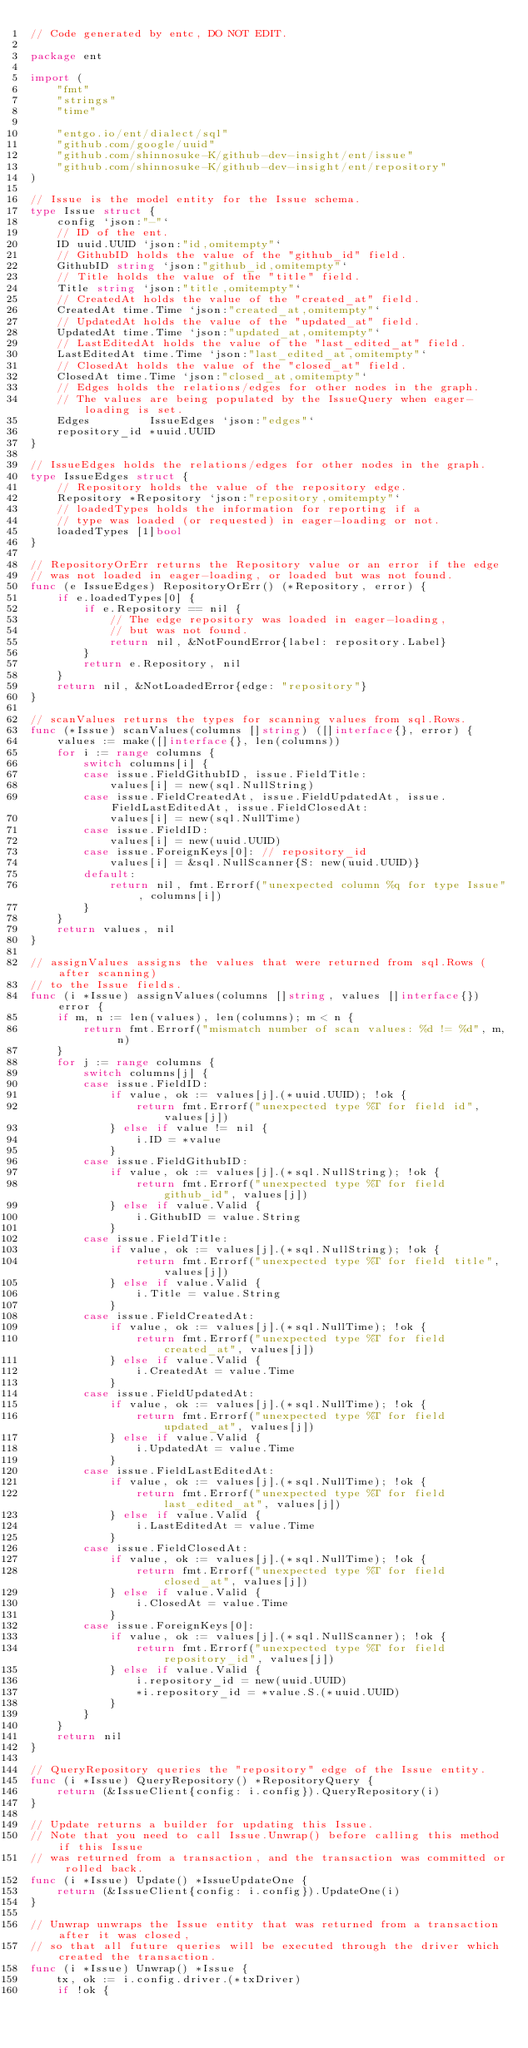<code> <loc_0><loc_0><loc_500><loc_500><_Go_>// Code generated by entc, DO NOT EDIT.

package ent

import (
	"fmt"
	"strings"
	"time"

	"entgo.io/ent/dialect/sql"
	"github.com/google/uuid"
	"github.com/shinnosuke-K/github-dev-insight/ent/issue"
	"github.com/shinnosuke-K/github-dev-insight/ent/repository"
)

// Issue is the model entity for the Issue schema.
type Issue struct {
	config `json:"-"`
	// ID of the ent.
	ID uuid.UUID `json:"id,omitempty"`
	// GithubID holds the value of the "github_id" field.
	GithubID string `json:"github_id,omitempty"`
	// Title holds the value of the "title" field.
	Title string `json:"title,omitempty"`
	// CreatedAt holds the value of the "created_at" field.
	CreatedAt time.Time `json:"created_at,omitempty"`
	// UpdatedAt holds the value of the "updated_at" field.
	UpdatedAt time.Time `json:"updated_at,omitempty"`
	// LastEditedAt holds the value of the "last_edited_at" field.
	LastEditedAt time.Time `json:"last_edited_at,omitempty"`
	// ClosedAt holds the value of the "closed_at" field.
	ClosedAt time.Time `json:"closed_at,omitempty"`
	// Edges holds the relations/edges for other nodes in the graph.
	// The values are being populated by the IssueQuery when eager-loading is set.
	Edges         IssueEdges `json:"edges"`
	repository_id *uuid.UUID
}

// IssueEdges holds the relations/edges for other nodes in the graph.
type IssueEdges struct {
	// Repository holds the value of the repository edge.
	Repository *Repository `json:"repository,omitempty"`
	// loadedTypes holds the information for reporting if a
	// type was loaded (or requested) in eager-loading or not.
	loadedTypes [1]bool
}

// RepositoryOrErr returns the Repository value or an error if the edge
// was not loaded in eager-loading, or loaded but was not found.
func (e IssueEdges) RepositoryOrErr() (*Repository, error) {
	if e.loadedTypes[0] {
		if e.Repository == nil {
			// The edge repository was loaded in eager-loading,
			// but was not found.
			return nil, &NotFoundError{label: repository.Label}
		}
		return e.Repository, nil
	}
	return nil, &NotLoadedError{edge: "repository"}
}

// scanValues returns the types for scanning values from sql.Rows.
func (*Issue) scanValues(columns []string) ([]interface{}, error) {
	values := make([]interface{}, len(columns))
	for i := range columns {
		switch columns[i] {
		case issue.FieldGithubID, issue.FieldTitle:
			values[i] = new(sql.NullString)
		case issue.FieldCreatedAt, issue.FieldUpdatedAt, issue.FieldLastEditedAt, issue.FieldClosedAt:
			values[i] = new(sql.NullTime)
		case issue.FieldID:
			values[i] = new(uuid.UUID)
		case issue.ForeignKeys[0]: // repository_id
			values[i] = &sql.NullScanner{S: new(uuid.UUID)}
		default:
			return nil, fmt.Errorf("unexpected column %q for type Issue", columns[i])
		}
	}
	return values, nil
}

// assignValues assigns the values that were returned from sql.Rows (after scanning)
// to the Issue fields.
func (i *Issue) assignValues(columns []string, values []interface{}) error {
	if m, n := len(values), len(columns); m < n {
		return fmt.Errorf("mismatch number of scan values: %d != %d", m, n)
	}
	for j := range columns {
		switch columns[j] {
		case issue.FieldID:
			if value, ok := values[j].(*uuid.UUID); !ok {
				return fmt.Errorf("unexpected type %T for field id", values[j])
			} else if value != nil {
				i.ID = *value
			}
		case issue.FieldGithubID:
			if value, ok := values[j].(*sql.NullString); !ok {
				return fmt.Errorf("unexpected type %T for field github_id", values[j])
			} else if value.Valid {
				i.GithubID = value.String
			}
		case issue.FieldTitle:
			if value, ok := values[j].(*sql.NullString); !ok {
				return fmt.Errorf("unexpected type %T for field title", values[j])
			} else if value.Valid {
				i.Title = value.String
			}
		case issue.FieldCreatedAt:
			if value, ok := values[j].(*sql.NullTime); !ok {
				return fmt.Errorf("unexpected type %T for field created_at", values[j])
			} else if value.Valid {
				i.CreatedAt = value.Time
			}
		case issue.FieldUpdatedAt:
			if value, ok := values[j].(*sql.NullTime); !ok {
				return fmt.Errorf("unexpected type %T for field updated_at", values[j])
			} else if value.Valid {
				i.UpdatedAt = value.Time
			}
		case issue.FieldLastEditedAt:
			if value, ok := values[j].(*sql.NullTime); !ok {
				return fmt.Errorf("unexpected type %T for field last_edited_at", values[j])
			} else if value.Valid {
				i.LastEditedAt = value.Time
			}
		case issue.FieldClosedAt:
			if value, ok := values[j].(*sql.NullTime); !ok {
				return fmt.Errorf("unexpected type %T for field closed_at", values[j])
			} else if value.Valid {
				i.ClosedAt = value.Time
			}
		case issue.ForeignKeys[0]:
			if value, ok := values[j].(*sql.NullScanner); !ok {
				return fmt.Errorf("unexpected type %T for field repository_id", values[j])
			} else if value.Valid {
				i.repository_id = new(uuid.UUID)
				*i.repository_id = *value.S.(*uuid.UUID)
			}
		}
	}
	return nil
}

// QueryRepository queries the "repository" edge of the Issue entity.
func (i *Issue) QueryRepository() *RepositoryQuery {
	return (&IssueClient{config: i.config}).QueryRepository(i)
}

// Update returns a builder for updating this Issue.
// Note that you need to call Issue.Unwrap() before calling this method if this Issue
// was returned from a transaction, and the transaction was committed or rolled back.
func (i *Issue) Update() *IssueUpdateOne {
	return (&IssueClient{config: i.config}).UpdateOne(i)
}

// Unwrap unwraps the Issue entity that was returned from a transaction after it was closed,
// so that all future queries will be executed through the driver which created the transaction.
func (i *Issue) Unwrap() *Issue {
	tx, ok := i.config.driver.(*txDriver)
	if !ok {</code> 